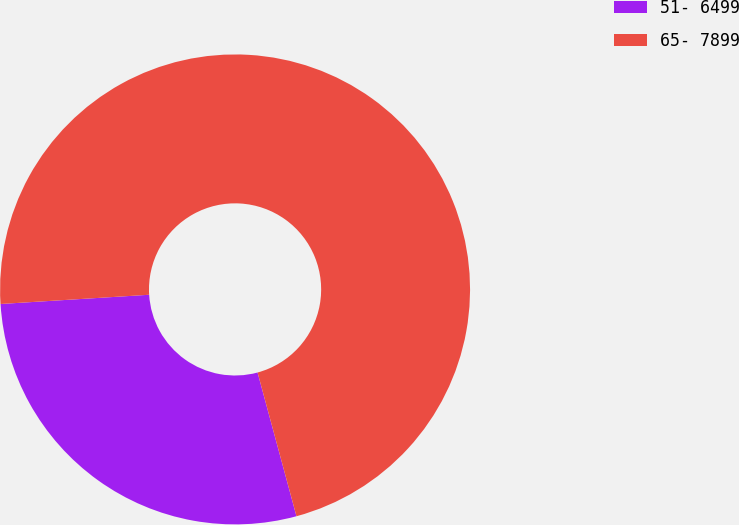Convert chart to OTSL. <chart><loc_0><loc_0><loc_500><loc_500><pie_chart><fcel>51- 6499<fcel>65- 7899<nl><fcel>28.22%<fcel>71.78%<nl></chart> 